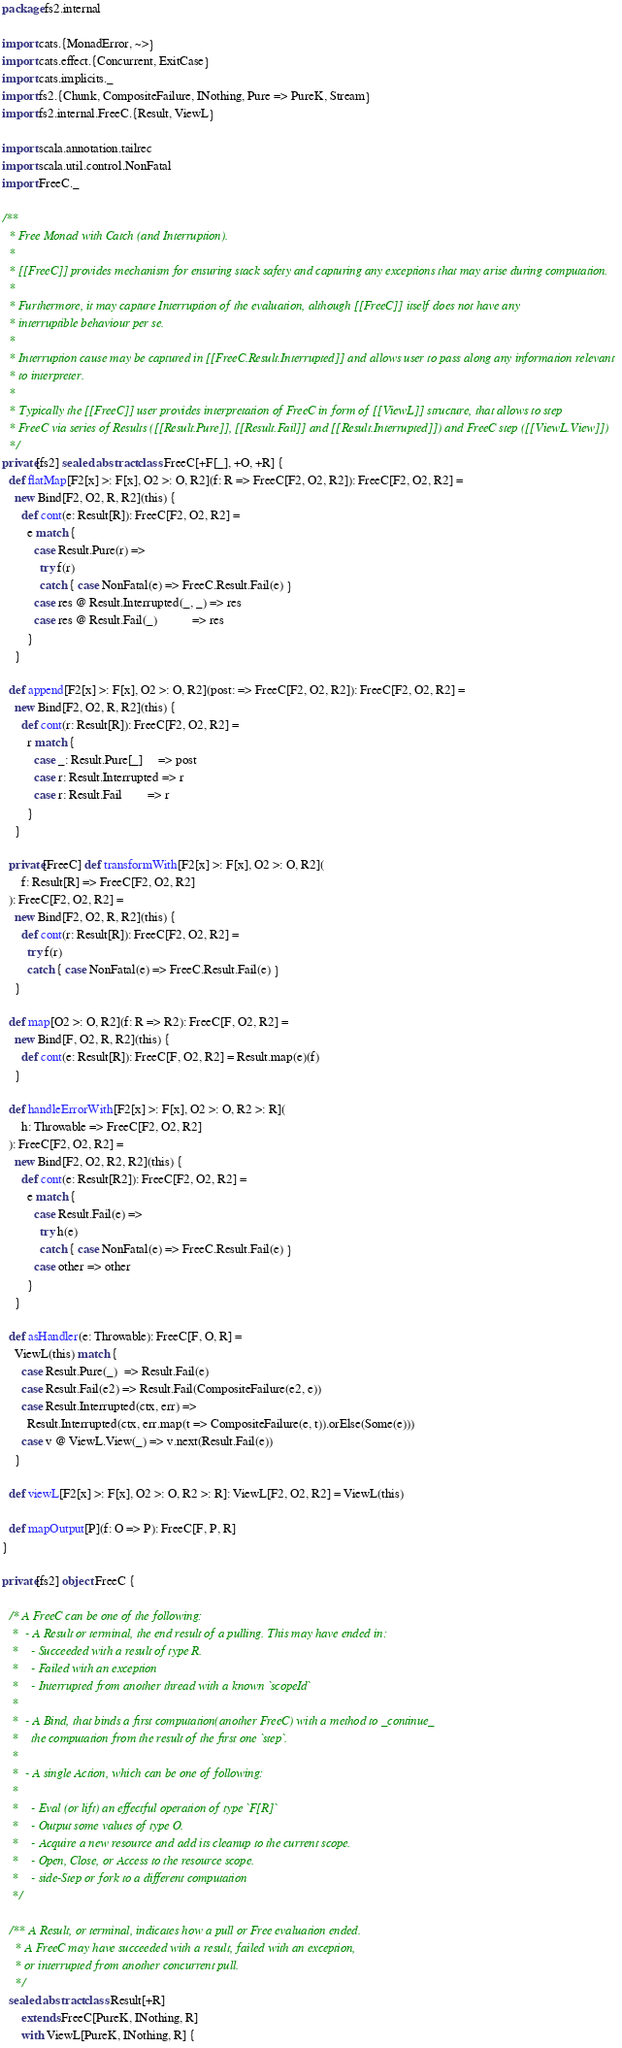Convert code to text. <code><loc_0><loc_0><loc_500><loc_500><_Scala_>package fs2.internal

import cats.{MonadError, ~>}
import cats.effect.{Concurrent, ExitCase}
import cats.implicits._
import fs2.{Chunk, CompositeFailure, INothing, Pure => PureK, Stream}
import fs2.internal.FreeC.{Result, ViewL}

import scala.annotation.tailrec
import scala.util.control.NonFatal
import FreeC._

/**
  * Free Monad with Catch (and Interruption).
  *
  * [[FreeC]] provides mechanism for ensuring stack safety and capturing any exceptions that may arise during computation.
  *
  * Furthermore, it may capture Interruption of the evaluation, although [[FreeC]] itself does not have any
  * interruptible behaviour per se.
  *
  * Interruption cause may be captured in [[FreeC.Result.Interrupted]] and allows user to pass along any information relevant
  * to interpreter.
  *
  * Typically the [[FreeC]] user provides interpretation of FreeC in form of [[ViewL]] structure, that allows to step
  * FreeC via series of Results ([[Result.Pure]], [[Result.Fail]] and [[Result.Interrupted]]) and FreeC step ([[ViewL.View]])
  */
private[fs2] sealed abstract class FreeC[+F[_], +O, +R] {
  def flatMap[F2[x] >: F[x], O2 >: O, R2](f: R => FreeC[F2, O2, R2]): FreeC[F2, O2, R2] =
    new Bind[F2, O2, R, R2](this) {
      def cont(e: Result[R]): FreeC[F2, O2, R2] =
        e match {
          case Result.Pure(r) =>
            try f(r)
            catch { case NonFatal(e) => FreeC.Result.Fail(e) }
          case res @ Result.Interrupted(_, _) => res
          case res @ Result.Fail(_)           => res
        }
    }

  def append[F2[x] >: F[x], O2 >: O, R2](post: => FreeC[F2, O2, R2]): FreeC[F2, O2, R2] =
    new Bind[F2, O2, R, R2](this) {
      def cont(r: Result[R]): FreeC[F2, O2, R2] =
        r match {
          case _: Result.Pure[_]     => post
          case r: Result.Interrupted => r
          case r: Result.Fail        => r
        }
    }

  private[FreeC] def transformWith[F2[x] >: F[x], O2 >: O, R2](
      f: Result[R] => FreeC[F2, O2, R2]
  ): FreeC[F2, O2, R2] =
    new Bind[F2, O2, R, R2](this) {
      def cont(r: Result[R]): FreeC[F2, O2, R2] =
        try f(r)
        catch { case NonFatal(e) => FreeC.Result.Fail(e) }
    }

  def map[O2 >: O, R2](f: R => R2): FreeC[F, O2, R2] =
    new Bind[F, O2, R, R2](this) {
      def cont(e: Result[R]): FreeC[F, O2, R2] = Result.map(e)(f)
    }

  def handleErrorWith[F2[x] >: F[x], O2 >: O, R2 >: R](
      h: Throwable => FreeC[F2, O2, R2]
  ): FreeC[F2, O2, R2] =
    new Bind[F2, O2, R2, R2](this) {
      def cont(e: Result[R2]): FreeC[F2, O2, R2] =
        e match {
          case Result.Fail(e) =>
            try h(e)
            catch { case NonFatal(e) => FreeC.Result.Fail(e) }
          case other => other
        }
    }

  def asHandler(e: Throwable): FreeC[F, O, R] =
    ViewL(this) match {
      case Result.Pure(_)  => Result.Fail(e)
      case Result.Fail(e2) => Result.Fail(CompositeFailure(e2, e))
      case Result.Interrupted(ctx, err) =>
        Result.Interrupted(ctx, err.map(t => CompositeFailure(e, t)).orElse(Some(e)))
      case v @ ViewL.View(_) => v.next(Result.Fail(e))
    }

  def viewL[F2[x] >: F[x], O2 >: O, R2 >: R]: ViewL[F2, O2, R2] = ViewL(this)

  def mapOutput[P](f: O => P): FreeC[F, P, R]
}

private[fs2] object FreeC {

  /* A FreeC can be one of the following:
   *  - A Result or terminal, the end result of a pulling. This may have ended in:
   *    - Succeeded with a result of type R.
   *    - Failed with an exception
   *    - Interrupted from another thread with a known `scopeId`
   *
   *  - A Bind, that binds a first computation(another FreeC) with a method to _continue_
   *    the computation from the result of the first one `step`.
   *
   *  - A single Action, which can be one of following:
   *
   *    - Eval (or lift) an effectful operation of type `F[R]`
   *    - Output some values of type O.
   *    - Acquire a new resource and add its cleanup to the current scope.
   *    - Open, Close, or Access to the resource scope.
   *    - side-Step or fork to a different computation
   */

  /** A Result, or terminal, indicates how a pull or Free evaluation ended.
    * A FreeC may have succeeded with a result, failed with an exception,
    * or interrupted from another concurrent pull.
    */
  sealed abstract class Result[+R]
      extends FreeC[PureK, INothing, R]
      with ViewL[PureK, INothing, R] {</code> 